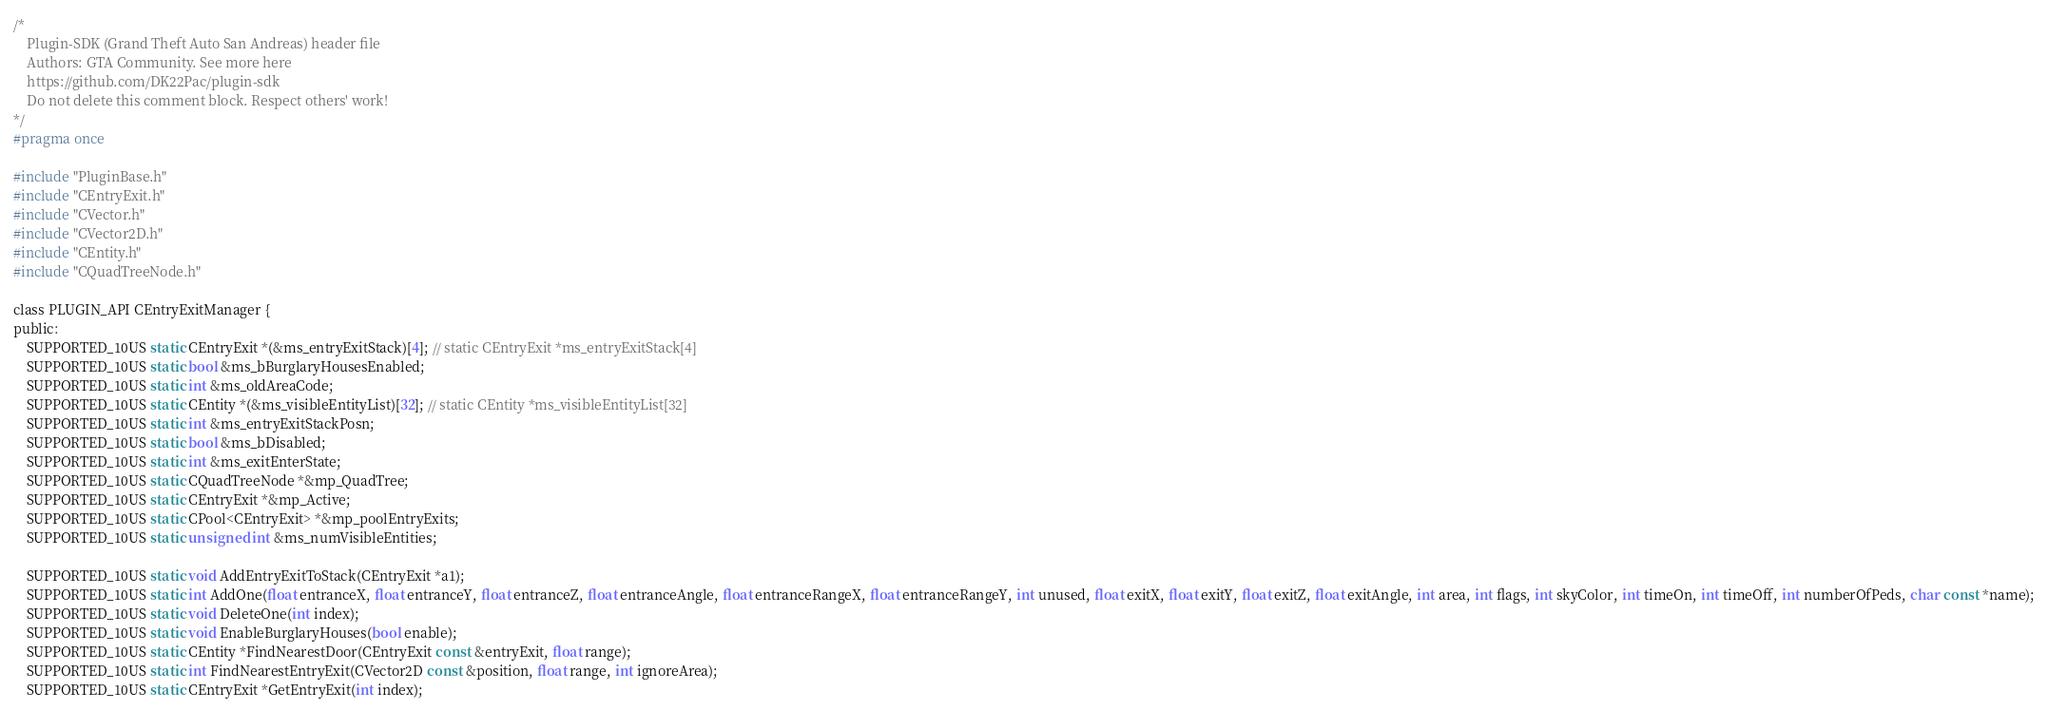<code> <loc_0><loc_0><loc_500><loc_500><_C_>/*
    Plugin-SDK (Grand Theft Auto San Andreas) header file
    Authors: GTA Community. See more here
    https://github.com/DK22Pac/plugin-sdk
    Do not delete this comment block. Respect others' work!
*/
#pragma once

#include "PluginBase.h"
#include "CEntryExit.h"
#include "CVector.h"
#include "CVector2D.h"
#include "CEntity.h"
#include "CQuadTreeNode.h"

class PLUGIN_API CEntryExitManager {
public:
    SUPPORTED_10US static CEntryExit *(&ms_entryExitStack)[4]; // static CEntryExit *ms_entryExitStack[4]
    SUPPORTED_10US static bool &ms_bBurglaryHousesEnabled;
    SUPPORTED_10US static int &ms_oldAreaCode;
    SUPPORTED_10US static CEntity *(&ms_visibleEntityList)[32]; // static CEntity *ms_visibleEntityList[32]
    SUPPORTED_10US static int &ms_entryExitStackPosn;
    SUPPORTED_10US static bool &ms_bDisabled;
    SUPPORTED_10US static int &ms_exitEnterState;
    SUPPORTED_10US static CQuadTreeNode *&mp_QuadTree;
    SUPPORTED_10US static CEntryExit *&mp_Active;
    SUPPORTED_10US static CPool<CEntryExit> *&mp_poolEntryExits;
    SUPPORTED_10US static unsigned int &ms_numVisibleEntities;

    SUPPORTED_10US static void AddEntryExitToStack(CEntryExit *a1);
    SUPPORTED_10US static int AddOne(float entranceX, float entranceY, float entranceZ, float entranceAngle, float entranceRangeX, float entranceRangeY, int unused, float exitX, float exitY, float exitZ, float exitAngle, int area, int flags, int skyColor, int timeOn, int timeOff, int numberOfPeds, char const *name);
    SUPPORTED_10US static void DeleteOne(int index);
    SUPPORTED_10US static void EnableBurglaryHouses(bool enable);
    SUPPORTED_10US static CEntity *FindNearestDoor(CEntryExit const &entryExit, float range);
    SUPPORTED_10US static int FindNearestEntryExit(CVector2D const &position, float range, int ignoreArea);
    SUPPORTED_10US static CEntryExit *GetEntryExit(int index);</code> 